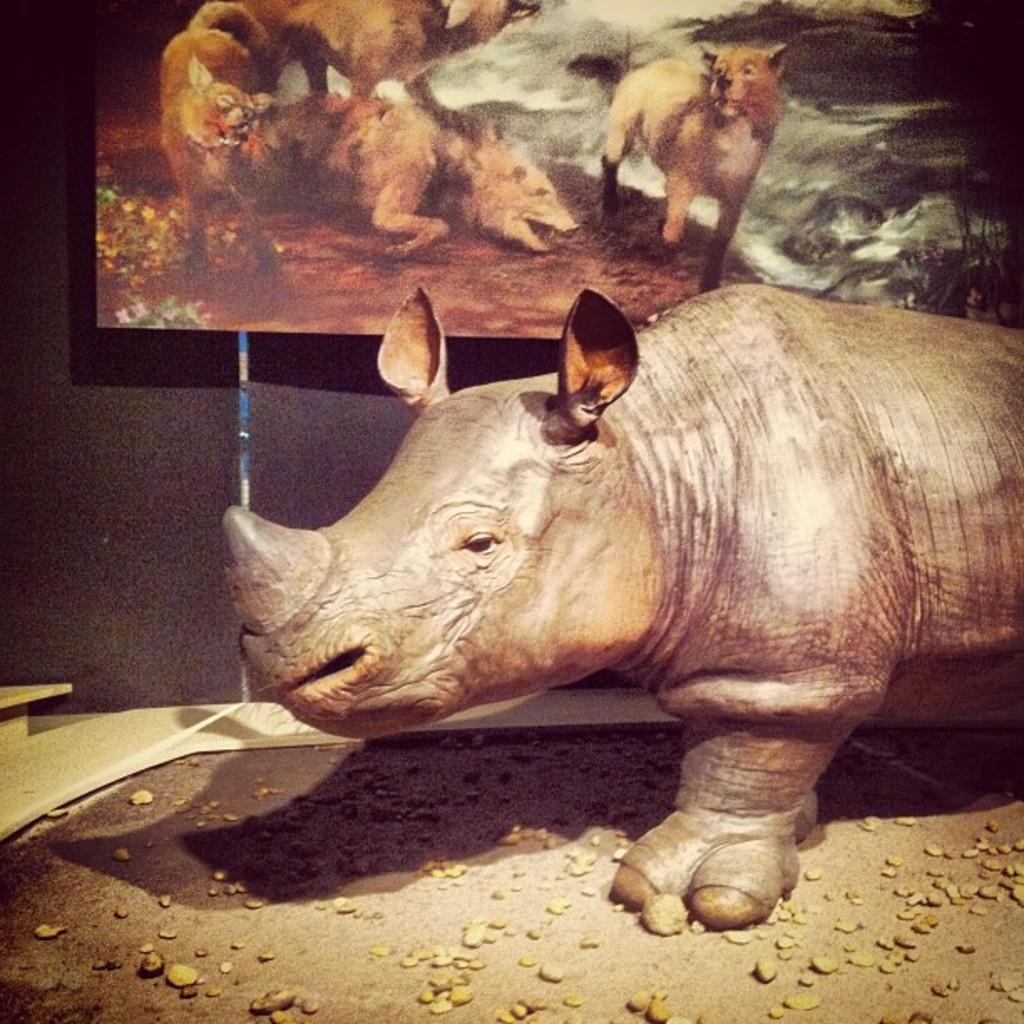What is the main subject of the image? There is a statue of a Rhinoceros in the image. Where is the statue located? The statue is present on the ground. What else can be seen in the image besides the statue? There is a painting on the wall in the image. In which direction is the Rhinoceros statue facing in the image? The provided facts do not mention the direction the Rhinoceros statue is facing, so it cannot be determined from the image. 